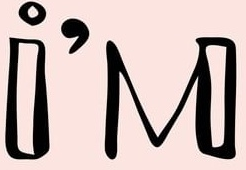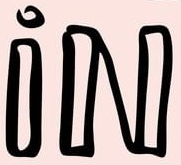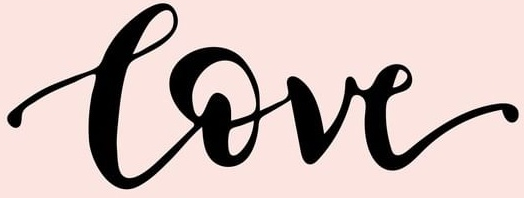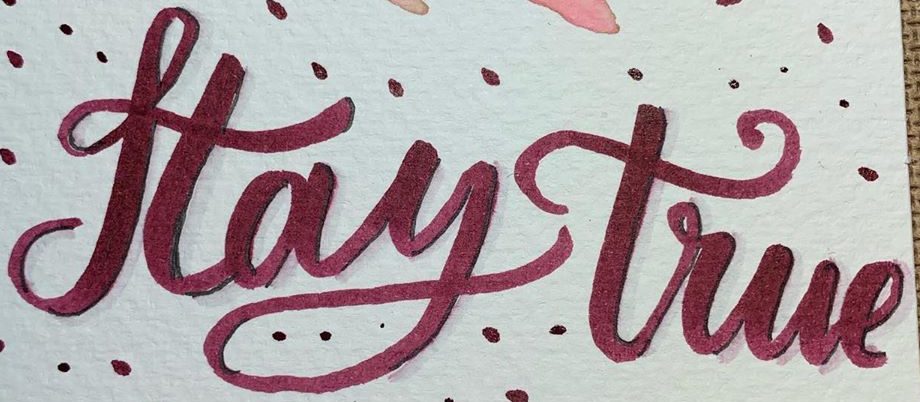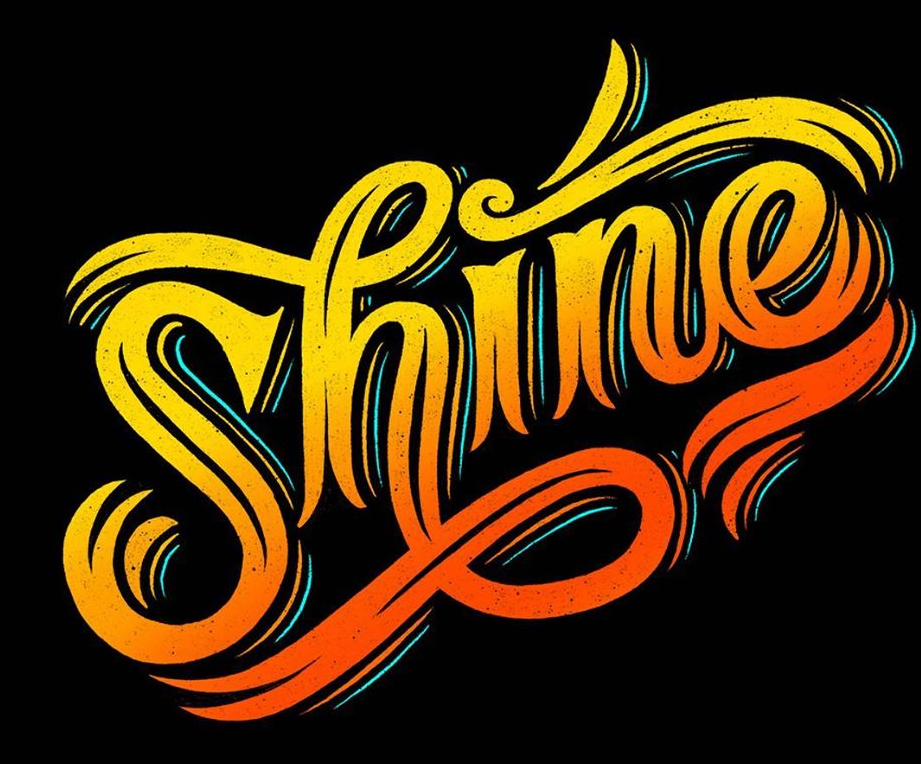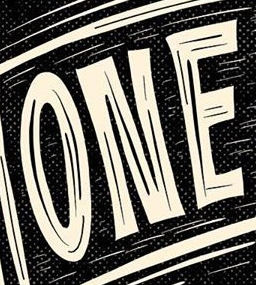Identify the words shown in these images in order, separated by a semicolon. i'M; iN; Love; Haytrue; Shine; ONE 